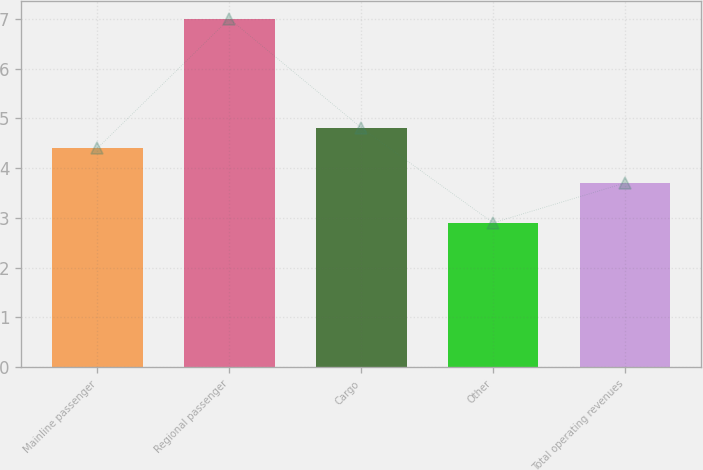Convert chart. <chart><loc_0><loc_0><loc_500><loc_500><bar_chart><fcel>Mainline passenger<fcel>Regional passenger<fcel>Cargo<fcel>Other<fcel>Total operating revenues<nl><fcel>4.4<fcel>7<fcel>4.81<fcel>2.9<fcel>3.7<nl></chart> 